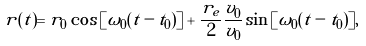Convert formula to latex. <formula><loc_0><loc_0><loc_500><loc_500>r ( t ) = r _ { 0 } \cos { [ \omega _ { 0 } ( t - t _ { 0 } ) ] } + \frac { r _ { e } } { 2 } \frac { v _ { 0 } } { v _ { 0 } } \sin { [ \omega _ { 0 } ( t - t _ { 0 } ) ] } ,</formula> 